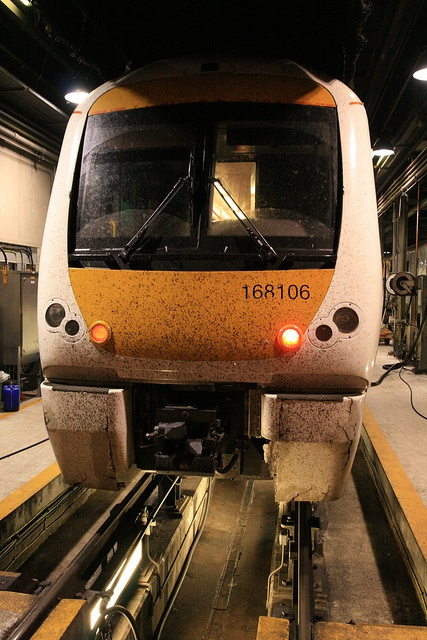Describe the objects in this image and their specific colors. I can see a train in darkgreen, black, maroon, brown, and ivory tones in this image. 